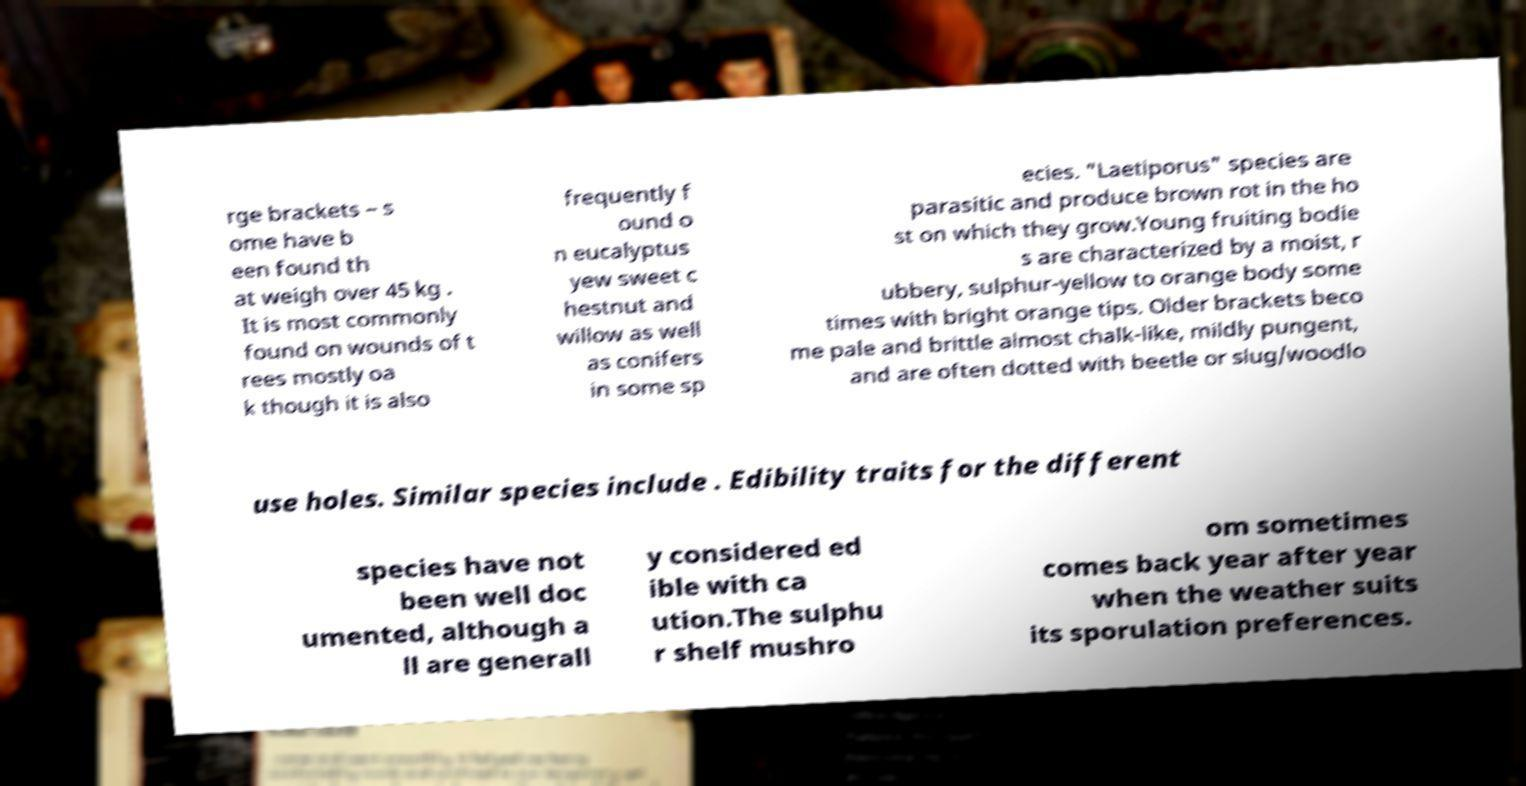Please identify and transcribe the text found in this image. rge brackets – s ome have b een found th at weigh over 45 kg . It is most commonly found on wounds of t rees mostly oa k though it is also frequently f ound o n eucalyptus yew sweet c hestnut and willow as well as conifers in some sp ecies. "Laetiporus" species are parasitic and produce brown rot in the ho st on which they grow.Young fruiting bodie s are characterized by a moist, r ubbery, sulphur-yellow to orange body some times with bright orange tips. Older brackets beco me pale and brittle almost chalk-like, mildly pungent, and are often dotted with beetle or slug/woodlo use holes. Similar species include . Edibility traits for the different species have not been well doc umented, although a ll are generall y considered ed ible with ca ution.The sulphu r shelf mushro om sometimes comes back year after year when the weather suits its sporulation preferences. 